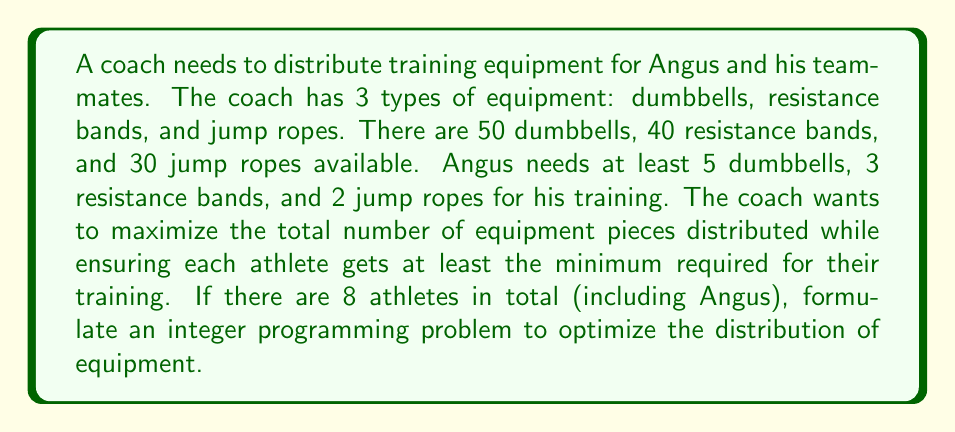What is the answer to this math problem? Let's approach this step-by-step:

1) Define variables:
   Let $x_1$, $x_2$, and $x_3$ be the number of dumbbells, resistance bands, and jump ropes given to each athlete, respectively.

2) Objective function:
   We want to maximize the total number of equipment pieces distributed to each athlete:
   $$\text{Maximize } Z = 8(x_1 + x_2 + x_3)$$

3) Constraints:
   a) Equipment availability:
      $$8x_1 \leq 50 \text{ (dumbbells)}$$
      $$8x_2 \leq 40 \text{ (resistance bands)}$$
      $$8x_3 \leq 30 \text{ (jump ropes)}$$

   b) Minimum requirements for each athlete:
      $$x_1 \geq 5 \text{ (dumbbells)}$$
      $$x_2 \geq 3 \text{ (resistance bands)}$$
      $$x_3 \geq 2 \text{ (jump ropes)}$$

   c) Integer constraint:
      $$x_1, x_2, x_3 \text{ are non-negative integers}$$

4) Complete integer programming formulation:

   $$\text{Maximize } Z = 8(x_1 + x_2 + x_3)$$
   
   Subject to:
   $$8x_1 \leq 50$$
   $$8x_2 \leq 40$$
   $$8x_3 \leq 30$$
   $$x_1 \geq 5$$
   $$x_2 \geq 3$$
   $$x_3 \geq 2$$
   $$x_1, x_2, x_3 \in \mathbb{Z}^+$$

This formulation ensures that the coach distributes the maximum number of equipment pieces while meeting the minimum requirements for each athlete, including Angus.
Answer: The integer programming formulation to optimize the distribution of training equipment is:

$$\text{Maximize } Z = 8(x_1 + x_2 + x_3)$$

Subject to:
$$8x_1 \leq 50$$
$$8x_2 \leq 40$$
$$8x_3 \leq 30$$
$$x_1 \geq 5$$
$$x_2 \geq 3$$
$$x_3 \geq 2$$
$$x_1, x_2, x_3 \in \mathbb{Z}^+$$

Where $x_1$, $x_2$, and $x_3$ represent the number of dumbbells, resistance bands, and jump ropes given to each athlete, respectively. 